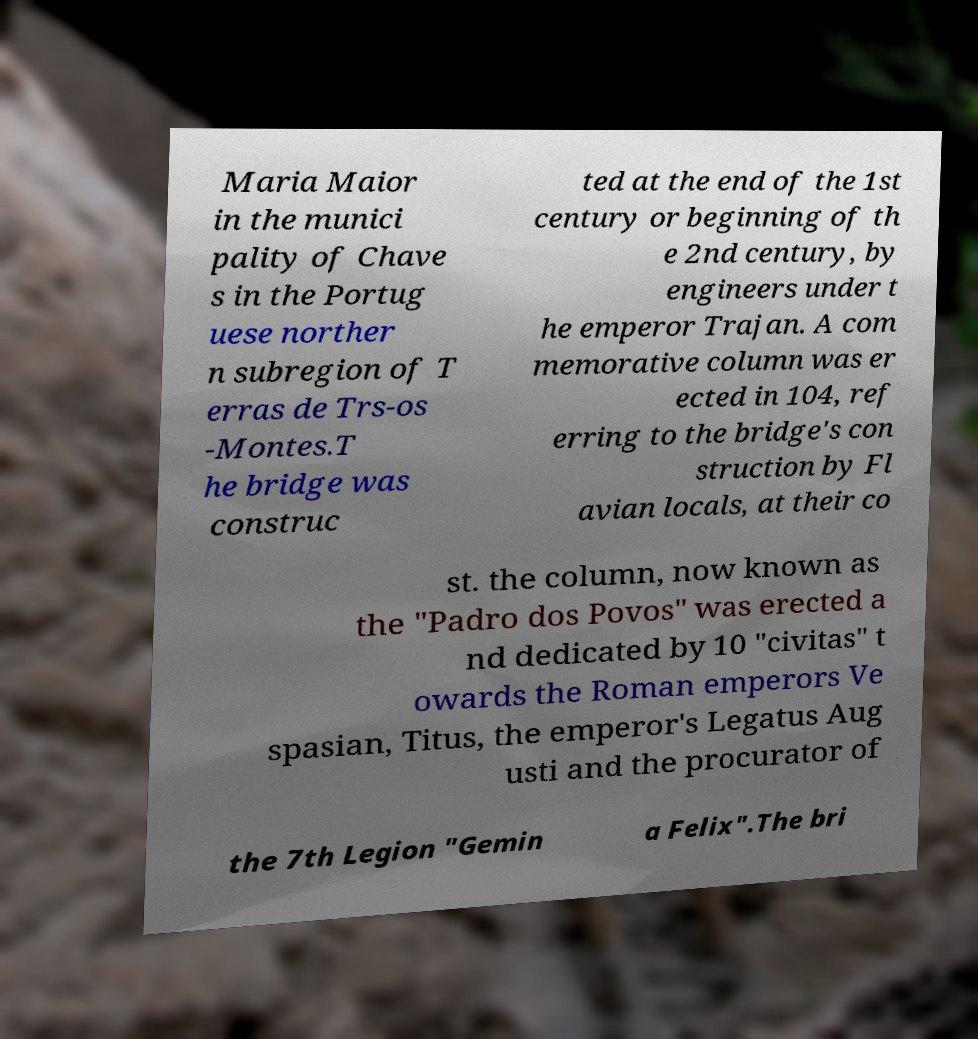Can you read and provide the text displayed in the image?This photo seems to have some interesting text. Can you extract and type it out for me? Maria Maior in the munici pality of Chave s in the Portug uese norther n subregion of T erras de Trs-os -Montes.T he bridge was construc ted at the end of the 1st century or beginning of th e 2nd century, by engineers under t he emperor Trajan. A com memorative column was er ected in 104, ref erring to the bridge's con struction by Fl avian locals, at their co st. the column, now known as the "Padro dos Povos" was erected a nd dedicated by 10 "civitas" t owards the Roman emperors Ve spasian, Titus, the emperor's Legatus Aug usti and the procurator of the 7th Legion "Gemin a Felix".The bri 